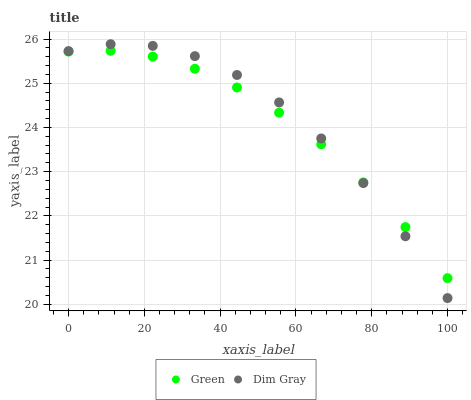Does Green have the minimum area under the curve?
Answer yes or no. Yes. Does Dim Gray have the maximum area under the curve?
Answer yes or no. Yes. Does Green have the maximum area under the curve?
Answer yes or no. No. Is Green the smoothest?
Answer yes or no. Yes. Is Dim Gray the roughest?
Answer yes or no. Yes. Is Green the roughest?
Answer yes or no. No. Does Dim Gray have the lowest value?
Answer yes or no. Yes. Does Green have the lowest value?
Answer yes or no. No. Does Dim Gray have the highest value?
Answer yes or no. Yes. Does Green have the highest value?
Answer yes or no. No. Does Green intersect Dim Gray?
Answer yes or no. Yes. Is Green less than Dim Gray?
Answer yes or no. No. Is Green greater than Dim Gray?
Answer yes or no. No. 